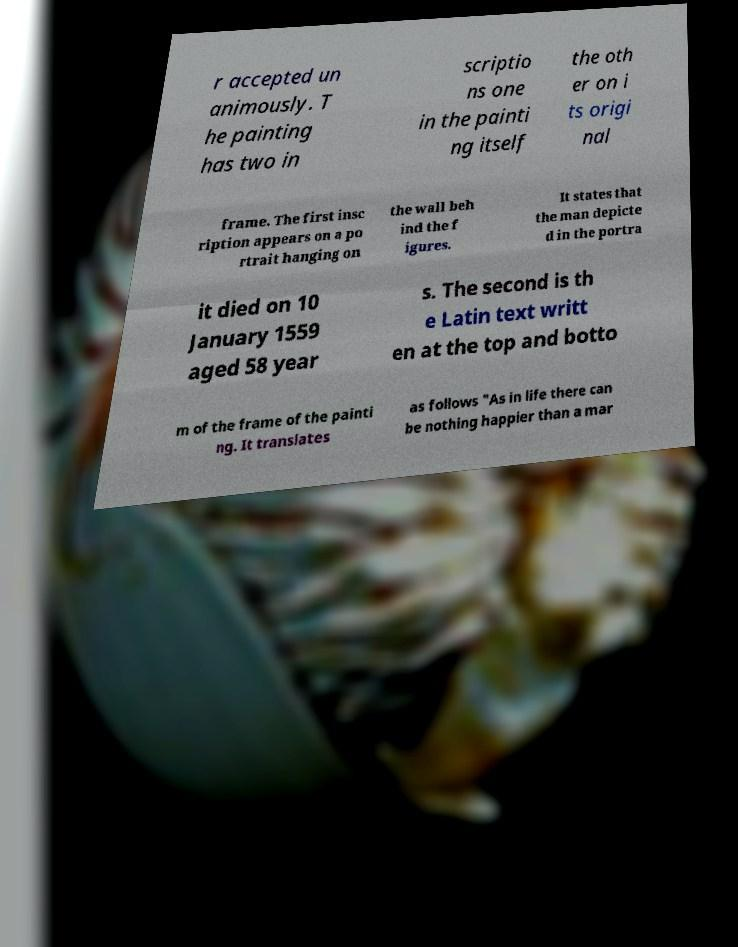Can you read and provide the text displayed in the image?This photo seems to have some interesting text. Can you extract and type it out for me? r accepted un animously. T he painting has two in scriptio ns one in the painti ng itself the oth er on i ts origi nal frame. The first insc ription appears on a po rtrait hanging on the wall beh ind the f igures. It states that the man depicte d in the portra it died on 10 January 1559 aged 58 year s. The second is th e Latin text writt en at the top and botto m of the frame of the painti ng. It translates as follows "As in life there can be nothing happier than a mar 